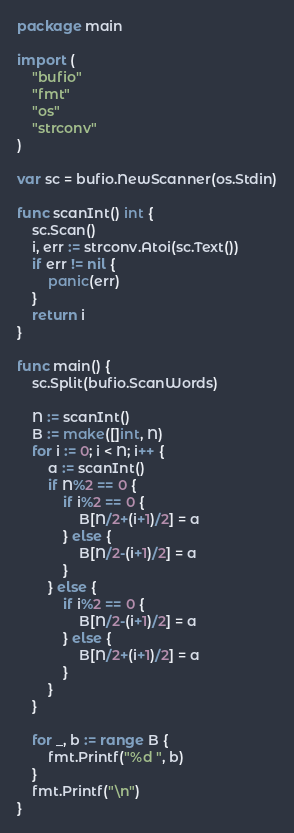Convert code to text. <code><loc_0><loc_0><loc_500><loc_500><_Go_>package main

import (
	"bufio"
	"fmt"
	"os"
	"strconv"
)

var sc = bufio.NewScanner(os.Stdin)

func scanInt() int {
	sc.Scan()
	i, err := strconv.Atoi(sc.Text())
	if err != nil {
		panic(err)
	}
	return i
}

func main() {
	sc.Split(bufio.ScanWords)

	N := scanInt()
	B := make([]int, N)
	for i := 0; i < N; i++ {
		a := scanInt()
		if N%2 == 0 {
			if i%2 == 0 {
				B[N/2+(i+1)/2] = a
			} else {
				B[N/2-(i+1)/2] = a
			}
		} else {
			if i%2 == 0 {
				B[N/2-(i+1)/2] = a
			} else {
				B[N/2+(i+1)/2] = a
			}
		}
	}

	for _, b := range B {
		fmt.Printf("%d ", b)
	}
	fmt.Printf("\n")
}
</code> 